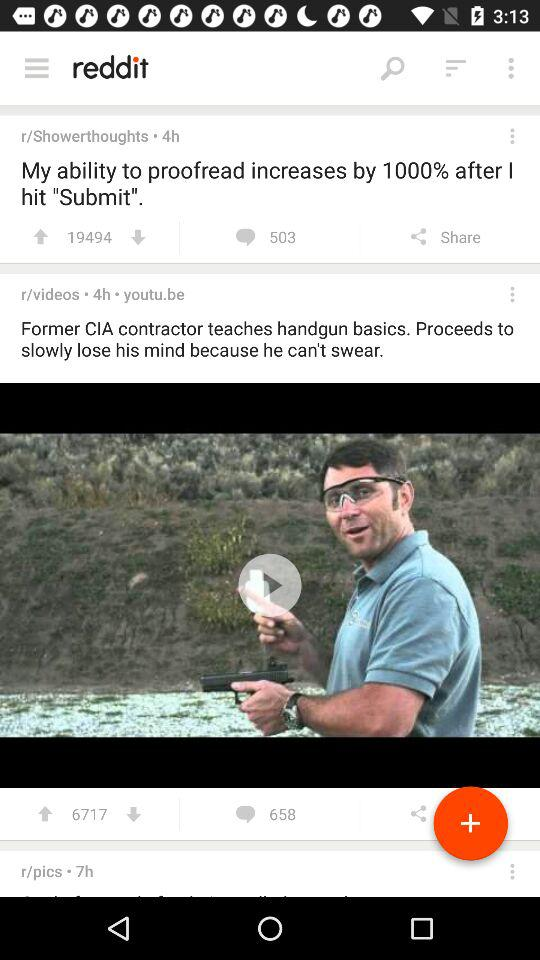What is the name of the application? The name of the application is "reddit". 